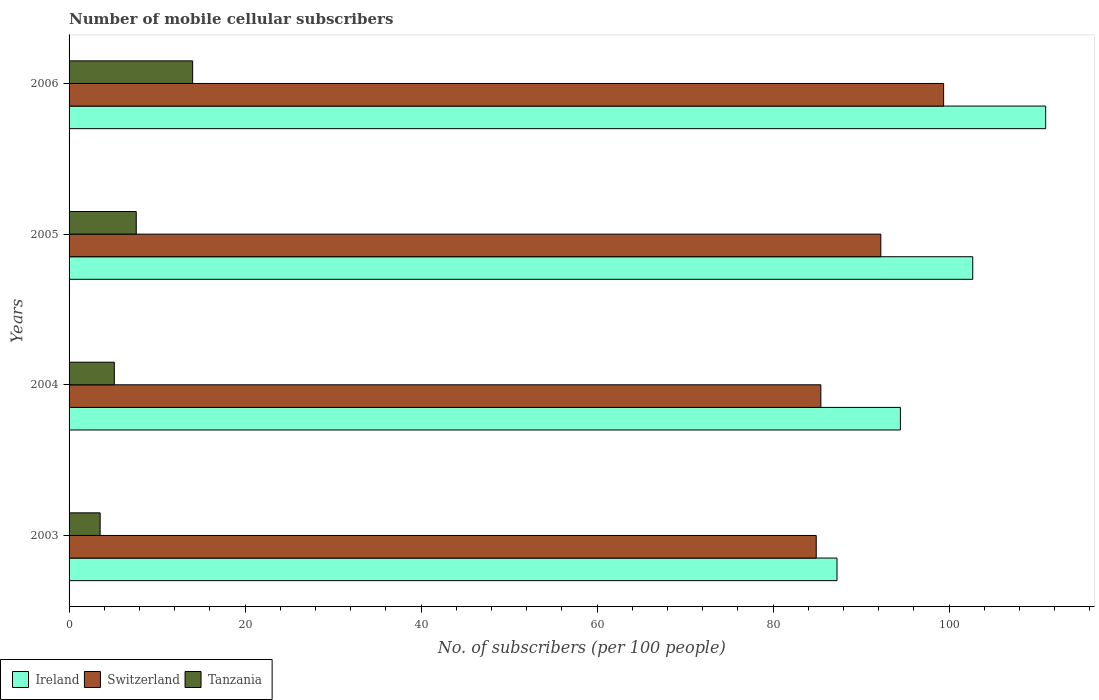How many different coloured bars are there?
Your answer should be compact. 3. How many groups of bars are there?
Provide a succinct answer. 4. Are the number of bars per tick equal to the number of legend labels?
Ensure brevity in your answer.  Yes. How many bars are there on the 3rd tick from the top?
Provide a short and direct response. 3. In how many cases, is the number of bars for a given year not equal to the number of legend labels?
Provide a succinct answer. 0. What is the number of mobile cellular subscribers in Tanzania in 2005?
Give a very brief answer. 7.63. Across all years, what is the maximum number of mobile cellular subscribers in Tanzania?
Offer a very short reply. 14.04. Across all years, what is the minimum number of mobile cellular subscribers in Ireland?
Your response must be concise. 87.27. In which year was the number of mobile cellular subscribers in Ireland maximum?
Provide a short and direct response. 2006. What is the total number of mobile cellular subscribers in Ireland in the graph?
Offer a very short reply. 395.42. What is the difference between the number of mobile cellular subscribers in Tanzania in 2003 and that in 2006?
Your answer should be very brief. -10.51. What is the difference between the number of mobile cellular subscribers in Ireland in 2005 and the number of mobile cellular subscribers in Tanzania in 2003?
Give a very brief answer. 99.16. What is the average number of mobile cellular subscribers in Tanzania per year?
Your answer should be very brief. 7.59. In the year 2006, what is the difference between the number of mobile cellular subscribers in Tanzania and number of mobile cellular subscribers in Ireland?
Ensure brevity in your answer.  -96.94. In how many years, is the number of mobile cellular subscribers in Ireland greater than 48 ?
Keep it short and to the point. 4. What is the ratio of the number of mobile cellular subscribers in Ireland in 2003 to that in 2005?
Your answer should be very brief. 0.85. Is the difference between the number of mobile cellular subscribers in Tanzania in 2003 and 2006 greater than the difference between the number of mobile cellular subscribers in Ireland in 2003 and 2006?
Give a very brief answer. Yes. What is the difference between the highest and the second highest number of mobile cellular subscribers in Switzerland?
Your response must be concise. 7.14. What is the difference between the highest and the lowest number of mobile cellular subscribers in Ireland?
Provide a succinct answer. 23.71. Is the sum of the number of mobile cellular subscribers in Tanzania in 2003 and 2004 greater than the maximum number of mobile cellular subscribers in Switzerland across all years?
Your answer should be very brief. No. What does the 3rd bar from the top in 2006 represents?
Make the answer very short. Ireland. What does the 3rd bar from the bottom in 2003 represents?
Give a very brief answer. Tanzania. Are all the bars in the graph horizontal?
Your answer should be compact. Yes. How many years are there in the graph?
Your response must be concise. 4. Does the graph contain grids?
Provide a succinct answer. No. Where does the legend appear in the graph?
Your answer should be compact. Bottom left. How are the legend labels stacked?
Ensure brevity in your answer.  Horizontal. What is the title of the graph?
Your response must be concise. Number of mobile cellular subscribers. Does "Honduras" appear as one of the legend labels in the graph?
Provide a succinct answer. No. What is the label or title of the X-axis?
Your response must be concise. No. of subscribers (per 100 people). What is the label or title of the Y-axis?
Provide a succinct answer. Years. What is the No. of subscribers (per 100 people) of Ireland in 2003?
Provide a succinct answer. 87.27. What is the No. of subscribers (per 100 people) of Switzerland in 2003?
Your answer should be very brief. 84.91. What is the No. of subscribers (per 100 people) of Tanzania in 2003?
Offer a terse response. 3.53. What is the No. of subscribers (per 100 people) in Ireland in 2004?
Ensure brevity in your answer.  94.47. What is the No. of subscribers (per 100 people) in Switzerland in 2004?
Provide a short and direct response. 85.43. What is the No. of subscribers (per 100 people) in Tanzania in 2004?
Keep it short and to the point. 5.14. What is the No. of subscribers (per 100 people) of Ireland in 2005?
Offer a terse response. 102.69. What is the No. of subscribers (per 100 people) of Switzerland in 2005?
Provide a succinct answer. 92.25. What is the No. of subscribers (per 100 people) in Tanzania in 2005?
Offer a very short reply. 7.63. What is the No. of subscribers (per 100 people) in Ireland in 2006?
Give a very brief answer. 110.98. What is the No. of subscribers (per 100 people) in Switzerland in 2006?
Your answer should be compact. 99.39. What is the No. of subscribers (per 100 people) in Tanzania in 2006?
Your response must be concise. 14.04. Across all years, what is the maximum No. of subscribers (per 100 people) of Ireland?
Your response must be concise. 110.98. Across all years, what is the maximum No. of subscribers (per 100 people) in Switzerland?
Make the answer very short. 99.39. Across all years, what is the maximum No. of subscribers (per 100 people) in Tanzania?
Provide a succinct answer. 14.04. Across all years, what is the minimum No. of subscribers (per 100 people) of Ireland?
Make the answer very short. 87.27. Across all years, what is the minimum No. of subscribers (per 100 people) in Switzerland?
Provide a short and direct response. 84.91. Across all years, what is the minimum No. of subscribers (per 100 people) in Tanzania?
Your answer should be compact. 3.53. What is the total No. of subscribers (per 100 people) in Ireland in the graph?
Offer a terse response. 395.42. What is the total No. of subscribers (per 100 people) in Switzerland in the graph?
Offer a terse response. 361.97. What is the total No. of subscribers (per 100 people) of Tanzania in the graph?
Your answer should be compact. 30.35. What is the difference between the No. of subscribers (per 100 people) in Ireland in 2003 and that in 2004?
Give a very brief answer. -7.21. What is the difference between the No. of subscribers (per 100 people) in Switzerland in 2003 and that in 2004?
Ensure brevity in your answer.  -0.53. What is the difference between the No. of subscribers (per 100 people) in Tanzania in 2003 and that in 2004?
Provide a succinct answer. -1.61. What is the difference between the No. of subscribers (per 100 people) in Ireland in 2003 and that in 2005?
Your answer should be very brief. -15.43. What is the difference between the No. of subscribers (per 100 people) in Switzerland in 2003 and that in 2005?
Ensure brevity in your answer.  -7.34. What is the difference between the No. of subscribers (per 100 people) in Tanzania in 2003 and that in 2005?
Offer a terse response. -4.1. What is the difference between the No. of subscribers (per 100 people) in Ireland in 2003 and that in 2006?
Offer a very short reply. -23.71. What is the difference between the No. of subscribers (per 100 people) of Switzerland in 2003 and that in 2006?
Offer a very short reply. -14.48. What is the difference between the No. of subscribers (per 100 people) of Tanzania in 2003 and that in 2006?
Your answer should be very brief. -10.51. What is the difference between the No. of subscribers (per 100 people) of Ireland in 2004 and that in 2005?
Offer a terse response. -8.22. What is the difference between the No. of subscribers (per 100 people) of Switzerland in 2004 and that in 2005?
Provide a short and direct response. -6.81. What is the difference between the No. of subscribers (per 100 people) of Tanzania in 2004 and that in 2005?
Offer a terse response. -2.49. What is the difference between the No. of subscribers (per 100 people) in Ireland in 2004 and that in 2006?
Give a very brief answer. -16.51. What is the difference between the No. of subscribers (per 100 people) in Switzerland in 2004 and that in 2006?
Offer a terse response. -13.95. What is the difference between the No. of subscribers (per 100 people) of Tanzania in 2004 and that in 2006?
Your answer should be very brief. -8.9. What is the difference between the No. of subscribers (per 100 people) of Ireland in 2005 and that in 2006?
Give a very brief answer. -8.29. What is the difference between the No. of subscribers (per 100 people) of Switzerland in 2005 and that in 2006?
Ensure brevity in your answer.  -7.14. What is the difference between the No. of subscribers (per 100 people) of Tanzania in 2005 and that in 2006?
Give a very brief answer. -6.41. What is the difference between the No. of subscribers (per 100 people) of Ireland in 2003 and the No. of subscribers (per 100 people) of Switzerland in 2004?
Offer a very short reply. 1.83. What is the difference between the No. of subscribers (per 100 people) of Ireland in 2003 and the No. of subscribers (per 100 people) of Tanzania in 2004?
Keep it short and to the point. 82.13. What is the difference between the No. of subscribers (per 100 people) of Switzerland in 2003 and the No. of subscribers (per 100 people) of Tanzania in 2004?
Keep it short and to the point. 79.77. What is the difference between the No. of subscribers (per 100 people) in Ireland in 2003 and the No. of subscribers (per 100 people) in Switzerland in 2005?
Offer a very short reply. -4.98. What is the difference between the No. of subscribers (per 100 people) of Ireland in 2003 and the No. of subscribers (per 100 people) of Tanzania in 2005?
Give a very brief answer. 79.63. What is the difference between the No. of subscribers (per 100 people) in Switzerland in 2003 and the No. of subscribers (per 100 people) in Tanzania in 2005?
Offer a very short reply. 77.27. What is the difference between the No. of subscribers (per 100 people) in Ireland in 2003 and the No. of subscribers (per 100 people) in Switzerland in 2006?
Provide a short and direct response. -12.12. What is the difference between the No. of subscribers (per 100 people) in Ireland in 2003 and the No. of subscribers (per 100 people) in Tanzania in 2006?
Give a very brief answer. 73.22. What is the difference between the No. of subscribers (per 100 people) of Switzerland in 2003 and the No. of subscribers (per 100 people) of Tanzania in 2006?
Provide a short and direct response. 70.87. What is the difference between the No. of subscribers (per 100 people) in Ireland in 2004 and the No. of subscribers (per 100 people) in Switzerland in 2005?
Make the answer very short. 2.23. What is the difference between the No. of subscribers (per 100 people) in Ireland in 2004 and the No. of subscribers (per 100 people) in Tanzania in 2005?
Provide a short and direct response. 86.84. What is the difference between the No. of subscribers (per 100 people) of Switzerland in 2004 and the No. of subscribers (per 100 people) of Tanzania in 2005?
Ensure brevity in your answer.  77.8. What is the difference between the No. of subscribers (per 100 people) in Ireland in 2004 and the No. of subscribers (per 100 people) in Switzerland in 2006?
Offer a terse response. -4.91. What is the difference between the No. of subscribers (per 100 people) in Ireland in 2004 and the No. of subscribers (per 100 people) in Tanzania in 2006?
Your answer should be very brief. 80.43. What is the difference between the No. of subscribers (per 100 people) of Switzerland in 2004 and the No. of subscribers (per 100 people) of Tanzania in 2006?
Offer a very short reply. 71.39. What is the difference between the No. of subscribers (per 100 people) of Ireland in 2005 and the No. of subscribers (per 100 people) of Switzerland in 2006?
Your answer should be compact. 3.31. What is the difference between the No. of subscribers (per 100 people) in Ireland in 2005 and the No. of subscribers (per 100 people) in Tanzania in 2006?
Your response must be concise. 88.65. What is the difference between the No. of subscribers (per 100 people) in Switzerland in 2005 and the No. of subscribers (per 100 people) in Tanzania in 2006?
Your answer should be very brief. 78.2. What is the average No. of subscribers (per 100 people) in Ireland per year?
Your response must be concise. 98.85. What is the average No. of subscribers (per 100 people) of Switzerland per year?
Ensure brevity in your answer.  90.49. What is the average No. of subscribers (per 100 people) of Tanzania per year?
Your answer should be compact. 7.59. In the year 2003, what is the difference between the No. of subscribers (per 100 people) of Ireland and No. of subscribers (per 100 people) of Switzerland?
Provide a succinct answer. 2.36. In the year 2003, what is the difference between the No. of subscribers (per 100 people) in Ireland and No. of subscribers (per 100 people) in Tanzania?
Provide a short and direct response. 83.74. In the year 2003, what is the difference between the No. of subscribers (per 100 people) in Switzerland and No. of subscribers (per 100 people) in Tanzania?
Ensure brevity in your answer.  81.38. In the year 2004, what is the difference between the No. of subscribers (per 100 people) of Ireland and No. of subscribers (per 100 people) of Switzerland?
Your answer should be compact. 9.04. In the year 2004, what is the difference between the No. of subscribers (per 100 people) in Ireland and No. of subscribers (per 100 people) in Tanzania?
Provide a short and direct response. 89.33. In the year 2004, what is the difference between the No. of subscribers (per 100 people) of Switzerland and No. of subscribers (per 100 people) of Tanzania?
Provide a short and direct response. 80.29. In the year 2005, what is the difference between the No. of subscribers (per 100 people) of Ireland and No. of subscribers (per 100 people) of Switzerland?
Offer a terse response. 10.45. In the year 2005, what is the difference between the No. of subscribers (per 100 people) in Ireland and No. of subscribers (per 100 people) in Tanzania?
Give a very brief answer. 95.06. In the year 2005, what is the difference between the No. of subscribers (per 100 people) in Switzerland and No. of subscribers (per 100 people) in Tanzania?
Offer a very short reply. 84.61. In the year 2006, what is the difference between the No. of subscribers (per 100 people) of Ireland and No. of subscribers (per 100 people) of Switzerland?
Offer a very short reply. 11.6. In the year 2006, what is the difference between the No. of subscribers (per 100 people) in Ireland and No. of subscribers (per 100 people) in Tanzania?
Offer a terse response. 96.94. In the year 2006, what is the difference between the No. of subscribers (per 100 people) of Switzerland and No. of subscribers (per 100 people) of Tanzania?
Provide a succinct answer. 85.34. What is the ratio of the No. of subscribers (per 100 people) of Ireland in 2003 to that in 2004?
Offer a very short reply. 0.92. What is the ratio of the No. of subscribers (per 100 people) of Tanzania in 2003 to that in 2004?
Your answer should be very brief. 0.69. What is the ratio of the No. of subscribers (per 100 people) of Ireland in 2003 to that in 2005?
Provide a succinct answer. 0.85. What is the ratio of the No. of subscribers (per 100 people) of Switzerland in 2003 to that in 2005?
Provide a short and direct response. 0.92. What is the ratio of the No. of subscribers (per 100 people) of Tanzania in 2003 to that in 2005?
Your answer should be compact. 0.46. What is the ratio of the No. of subscribers (per 100 people) in Ireland in 2003 to that in 2006?
Your response must be concise. 0.79. What is the ratio of the No. of subscribers (per 100 people) in Switzerland in 2003 to that in 2006?
Provide a succinct answer. 0.85. What is the ratio of the No. of subscribers (per 100 people) of Tanzania in 2003 to that in 2006?
Keep it short and to the point. 0.25. What is the ratio of the No. of subscribers (per 100 people) in Switzerland in 2004 to that in 2005?
Offer a terse response. 0.93. What is the ratio of the No. of subscribers (per 100 people) of Tanzania in 2004 to that in 2005?
Provide a succinct answer. 0.67. What is the ratio of the No. of subscribers (per 100 people) of Ireland in 2004 to that in 2006?
Keep it short and to the point. 0.85. What is the ratio of the No. of subscribers (per 100 people) in Switzerland in 2004 to that in 2006?
Your response must be concise. 0.86. What is the ratio of the No. of subscribers (per 100 people) in Tanzania in 2004 to that in 2006?
Offer a very short reply. 0.37. What is the ratio of the No. of subscribers (per 100 people) in Ireland in 2005 to that in 2006?
Your answer should be very brief. 0.93. What is the ratio of the No. of subscribers (per 100 people) in Switzerland in 2005 to that in 2006?
Your answer should be very brief. 0.93. What is the ratio of the No. of subscribers (per 100 people) of Tanzania in 2005 to that in 2006?
Make the answer very short. 0.54. What is the difference between the highest and the second highest No. of subscribers (per 100 people) of Ireland?
Offer a terse response. 8.29. What is the difference between the highest and the second highest No. of subscribers (per 100 people) of Switzerland?
Keep it short and to the point. 7.14. What is the difference between the highest and the second highest No. of subscribers (per 100 people) in Tanzania?
Ensure brevity in your answer.  6.41. What is the difference between the highest and the lowest No. of subscribers (per 100 people) of Ireland?
Provide a succinct answer. 23.71. What is the difference between the highest and the lowest No. of subscribers (per 100 people) of Switzerland?
Your answer should be compact. 14.48. What is the difference between the highest and the lowest No. of subscribers (per 100 people) of Tanzania?
Provide a succinct answer. 10.51. 